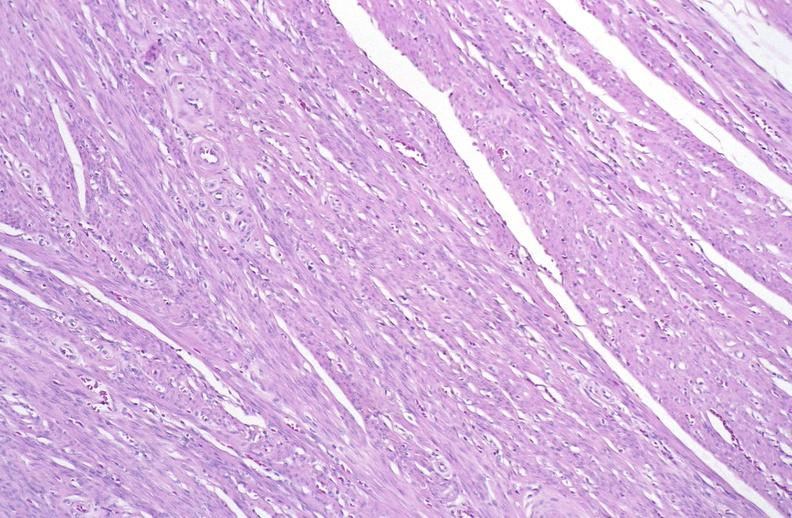what does this image show?
Answer the question using a single word or phrase. Normal uterus 